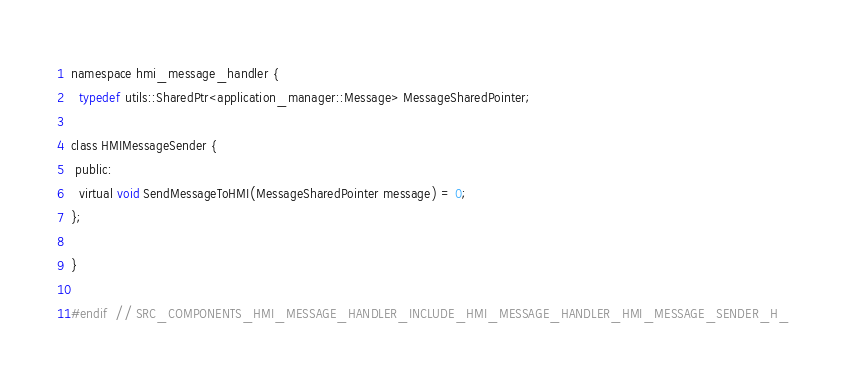Convert code to text. <code><loc_0><loc_0><loc_500><loc_500><_C_>namespace hmi_message_handler {
  typedef utils::SharedPtr<application_manager::Message> MessageSharedPointer;

class HMIMessageSender {
 public:
  virtual void SendMessageToHMI(MessageSharedPointer message) = 0;
};

}

#endif  // SRC_COMPONENTS_HMI_MESSAGE_HANDLER_INCLUDE_HMI_MESSAGE_HANDLER_HMI_MESSAGE_SENDER_H_
</code> 